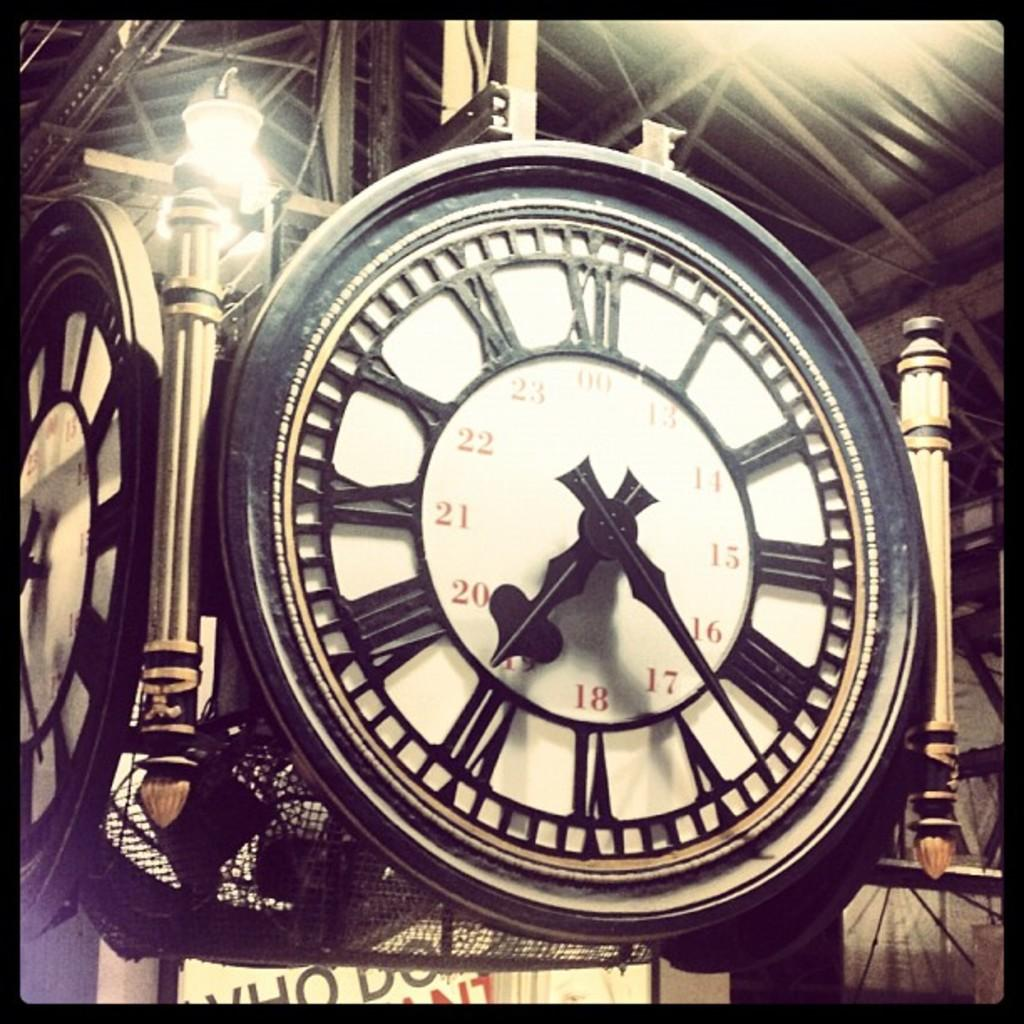Provide a one-sentence caption for the provided image. Clock which shows the hands at 17 and 19. 